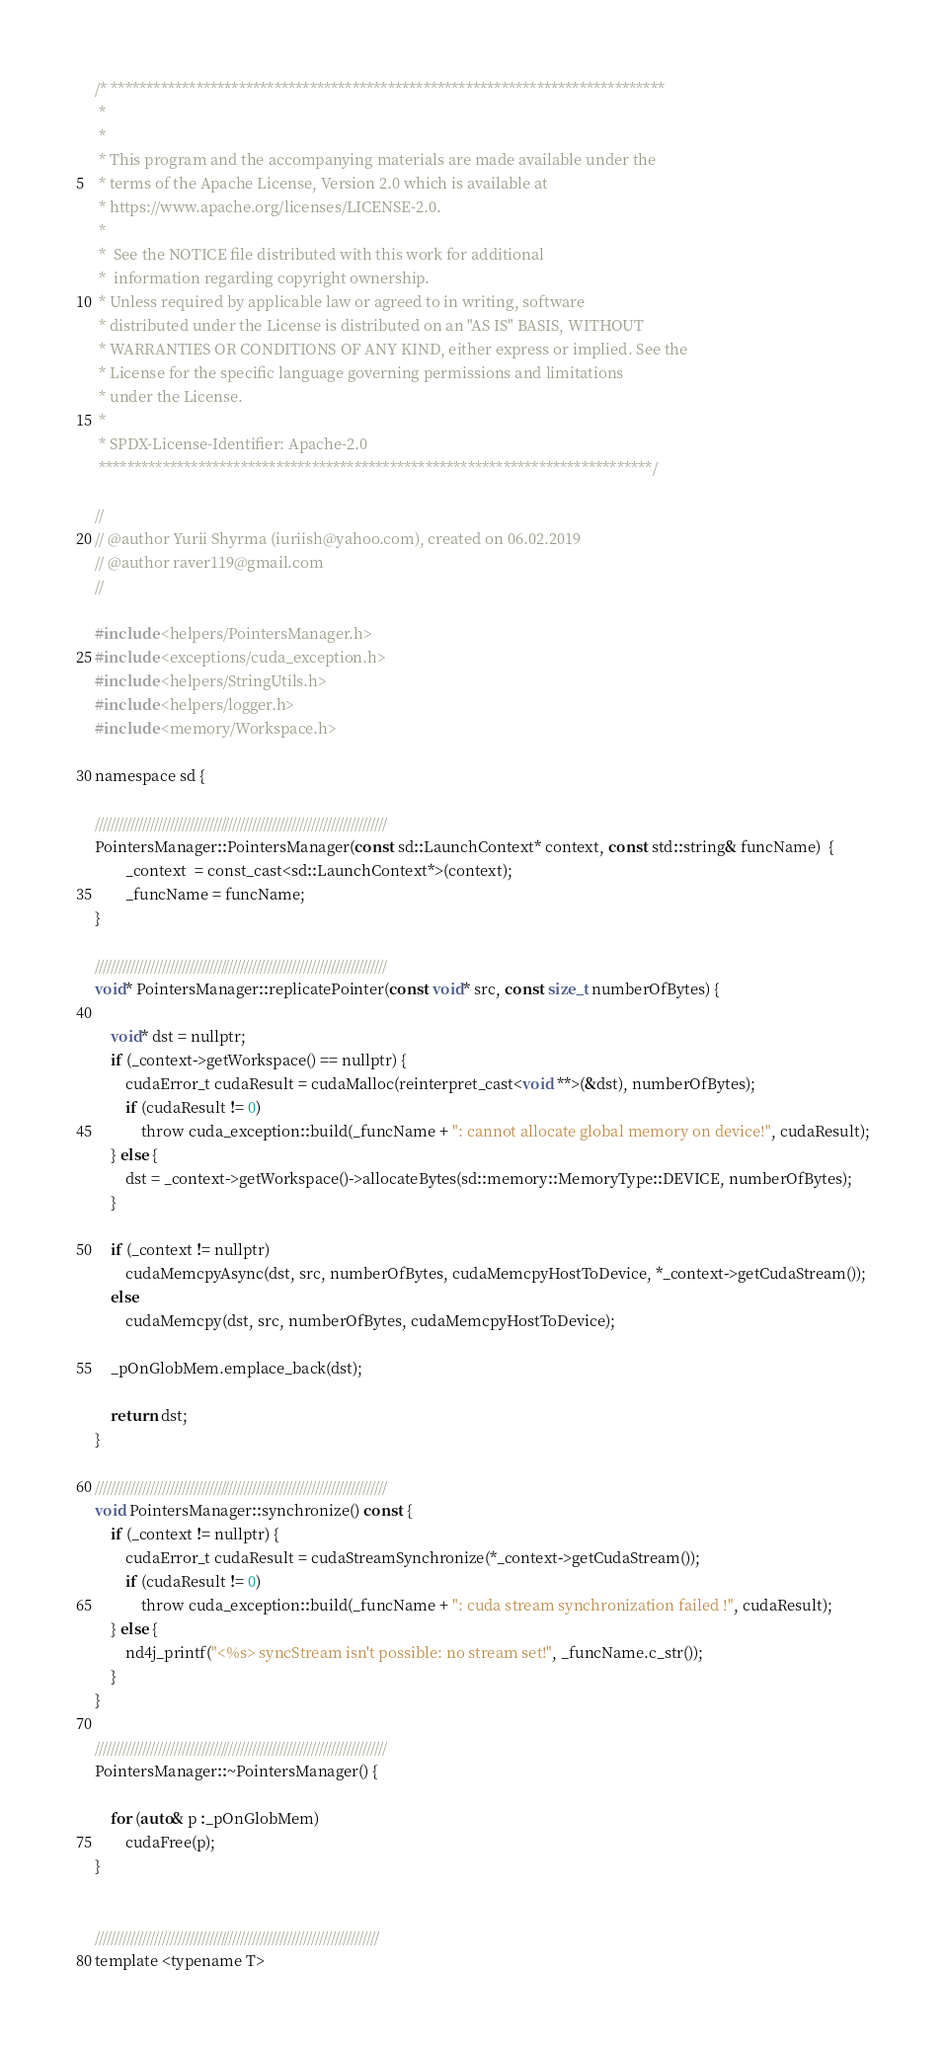<code> <loc_0><loc_0><loc_500><loc_500><_Cuda_>/* ******************************************************************************
 *
 *
 * This program and the accompanying materials are made available under the
 * terms of the Apache License, Version 2.0 which is available at
 * https://www.apache.org/licenses/LICENSE-2.0.
 *
 *  See the NOTICE file distributed with this work for additional
 *  information regarding copyright ownership.
 * Unless required by applicable law or agreed to in writing, software
 * distributed under the License is distributed on an "AS IS" BASIS, WITHOUT
 * WARRANTIES OR CONDITIONS OF ANY KIND, either express or implied. See the
 * License for the specific language governing permissions and limitations
 * under the License.
 *
 * SPDX-License-Identifier: Apache-2.0
 ******************************************************************************/

//
// @author Yurii Shyrma (iuriish@yahoo.com), created on 06.02.2019
// @author raver119@gmail.com
//

#include <helpers/PointersManager.h>
#include <exceptions/cuda_exception.h>
#include <helpers/StringUtils.h>
#include <helpers/logger.h>
#include <memory/Workspace.h>

namespace sd {

//////////////////////////////////////////////////////////////////////////
PointersManager::PointersManager(const sd::LaunchContext* context, const std::string& funcName)  {
        _context  = const_cast<sd::LaunchContext*>(context);
        _funcName = funcName;
}

//////////////////////////////////////////////////////////////////////////
void* PointersManager::replicatePointer(const void* src, const size_t numberOfBytes) {

	void* dst = nullptr;
	if (_context->getWorkspace() == nullptr) {
        cudaError_t cudaResult = cudaMalloc(reinterpret_cast<void **>(&dst), numberOfBytes);
        if (cudaResult != 0)
            throw cuda_exception::build(_funcName + ": cannot allocate global memory on device!", cudaResult);
    } else {
	    dst = _context->getWorkspace()->allocateBytes(sd::memory::MemoryType::DEVICE, numberOfBytes);
	}

    if (_context != nullptr)
        cudaMemcpyAsync(dst, src, numberOfBytes, cudaMemcpyHostToDevice, *_context->getCudaStream());
    else
        cudaMemcpy(dst, src, numberOfBytes, cudaMemcpyHostToDevice);

    _pOnGlobMem.emplace_back(dst);

    return dst;
}

//////////////////////////////////////////////////////////////////////////
void PointersManager::synchronize() const {
    if (_context != nullptr) {
        cudaError_t cudaResult = cudaStreamSynchronize(*_context->getCudaStream());
        if (cudaResult != 0)
            throw cuda_exception::build(_funcName + ": cuda stream synchronization failed !", cudaResult);
    } else {
        nd4j_printf("<%s> syncStream isn't possible: no stream set!", _funcName.c_str());
    }
}

//////////////////////////////////////////////////////////////////////////
PointersManager::~PointersManager() {

    for (auto& p :_pOnGlobMem)
        cudaFree(p);
}


////////////////////////////////////////////////////////////////////////
template <typename T></code> 